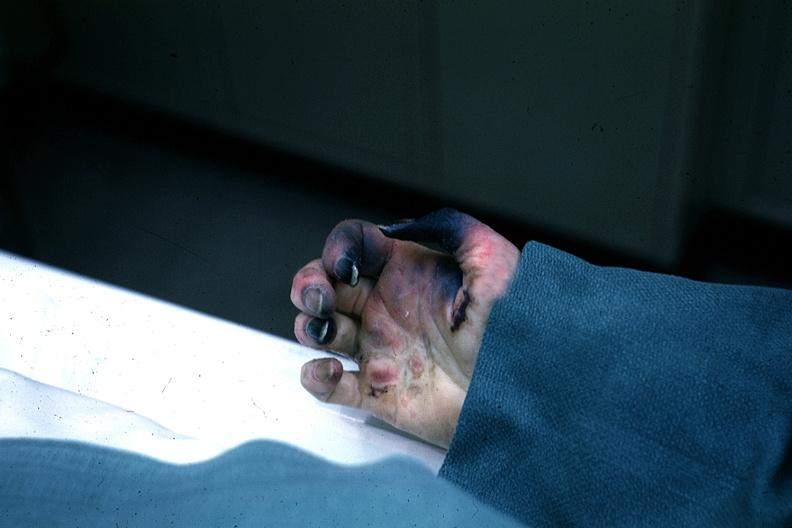s excellent gangrenous necrosis of fingers said to be due to embolism?
Answer the question using a single word or phrase. Yes 